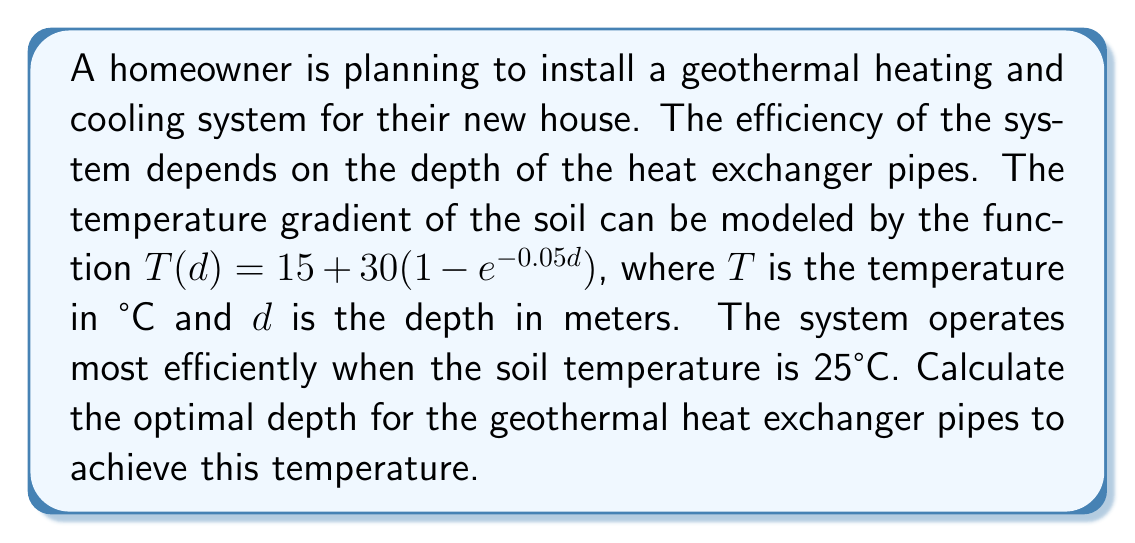Teach me how to tackle this problem. To solve this problem, we need to find the depth $d$ where the temperature function $T(d)$ equals 25°C. Let's approach this step-by-step:

1) We start with the given temperature function:
   $T(d) = 15 + 30(1 - e^{-0.05d})$

2) We want to find $d$ when $T(d) = 25$, so we set up the equation:
   $25 = 15 + 30(1 - e^{-0.05d})$

3) Subtract 15 from both sides:
   $10 = 30(1 - e^{-0.05d})$

4) Divide both sides by 30:
   $\frac{1}{3} = 1 - e^{-0.05d}$

5) Subtract 1 from both sides:
   $-\frac{2}{3} = -e^{-0.05d}$

6) Multiply both sides by -1:
   $\frac{2}{3} = e^{-0.05d}$

7) Take the natural logarithm of both sides:
   $\ln(\frac{2}{3}) = -0.05d$

8) Divide both sides by -0.05:
   $\frac{\ln(\frac{2}{3})}{-0.05} = d$

9) Calculate the value:
   $d \approx 8.1093$ meters

Therefore, the optimal depth for the geothermal heat exchanger pipes is approximately 8.11 meters.
Answer: The optimal depth for the geothermal heat exchanger pipes is approximately 8.11 meters. 